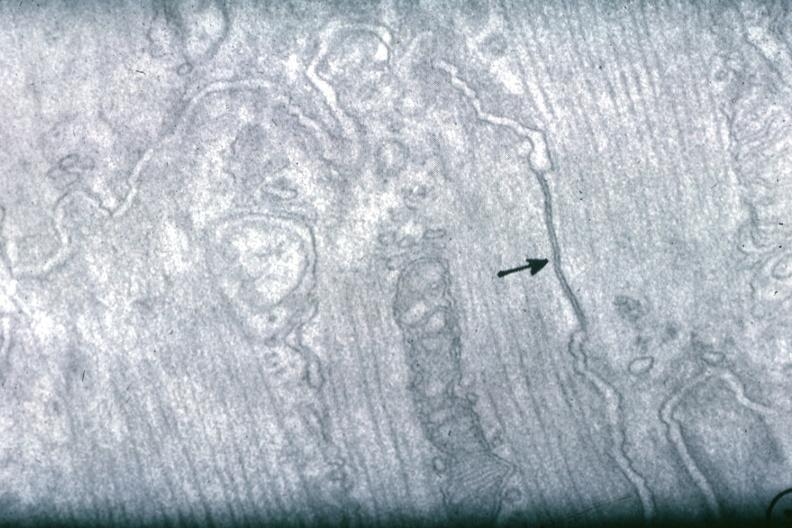s cardiovascular present?
Answer the question using a single word or phrase. Yes 